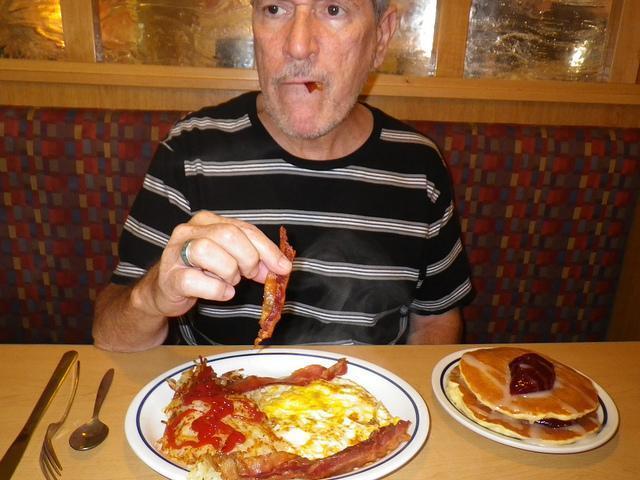Verify the accuracy of this image caption: "The person is at the right side of the dining table.".
Answer yes or no. No. 